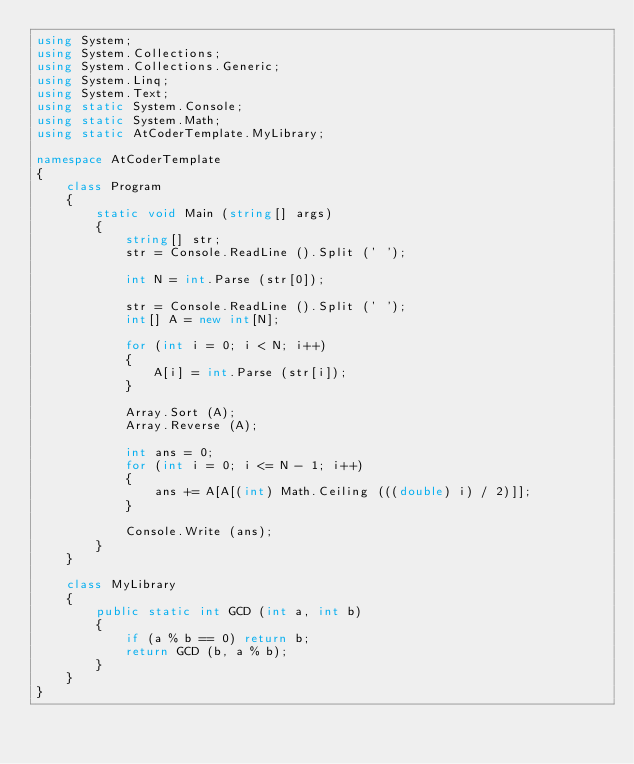<code> <loc_0><loc_0><loc_500><loc_500><_C#_>using System;
using System.Collections;
using System.Collections.Generic;
using System.Linq;
using System.Text;
using static System.Console;
using static System.Math;
using static AtCoderTemplate.MyLibrary;

namespace AtCoderTemplate
{
    class Program
    {
        static void Main (string[] args)
        {
            string[] str;
            str = Console.ReadLine ().Split (' ');

            int N = int.Parse (str[0]);

            str = Console.ReadLine ().Split (' ');
            int[] A = new int[N];

            for (int i = 0; i < N; i++)
            {
                A[i] = int.Parse (str[i]);
            }

            Array.Sort (A);
            Array.Reverse (A);

            int ans = 0;
            for (int i = 0; i <= N - 1; i++)
            {
                ans += A[A[(int) Math.Ceiling (((double) i) / 2)]];
            }

            Console.Write (ans);
        }
    }

    class MyLibrary
    {
        public static int GCD (int a, int b)
        {
            if (a % b == 0) return b;
            return GCD (b, a % b);
        }
    }
}</code> 